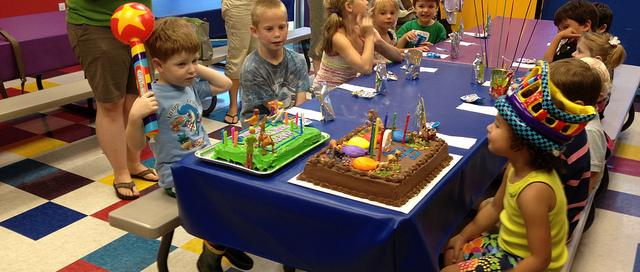What relationship might these two children with the birthday cakes likely have?

Choices:
A) random strangers
B) enemies
C) they're twins
D) none they're twins 